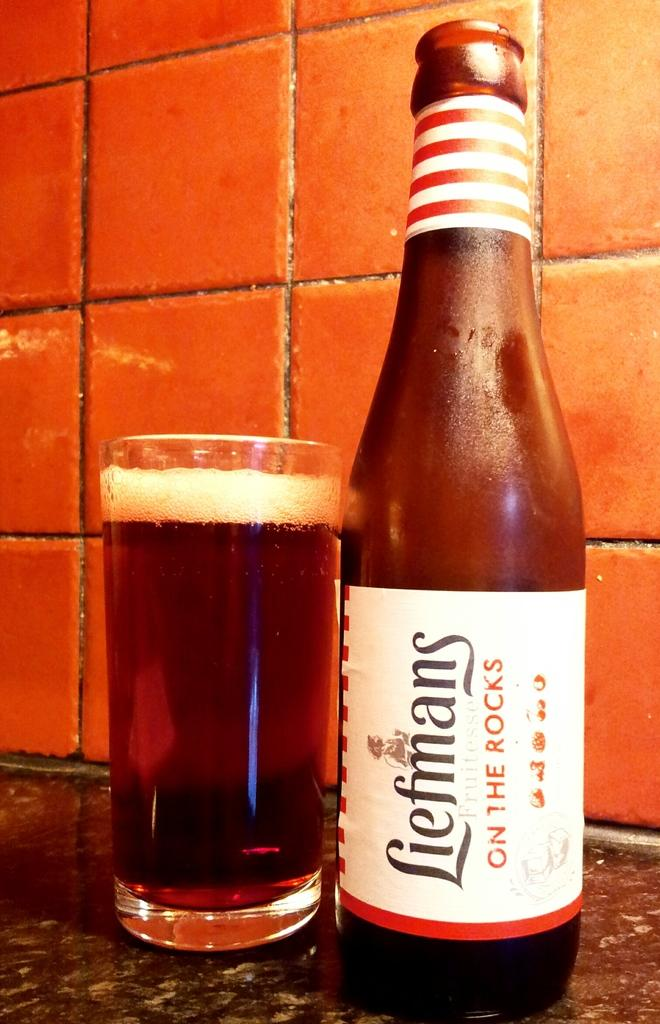What can be seen in the image that contains liquid? There is a glass filled with liquid in the image. What else is present in the image that also contains liquid? There is a bottle in the image. Where are the bottle and glass located in the image? The bottle and glass are placed on a black surface. What can be seen in the background of the image? There is a tile wall in the background of the image. What decorative elements are present on the bottle? There are stickers on the bottle. What type of discussion is taking place between the zebra and the pipe in the image? There is no zebra or pipe present in the image; it only features a bottle, a glass, a black surface, and a tile wall. 